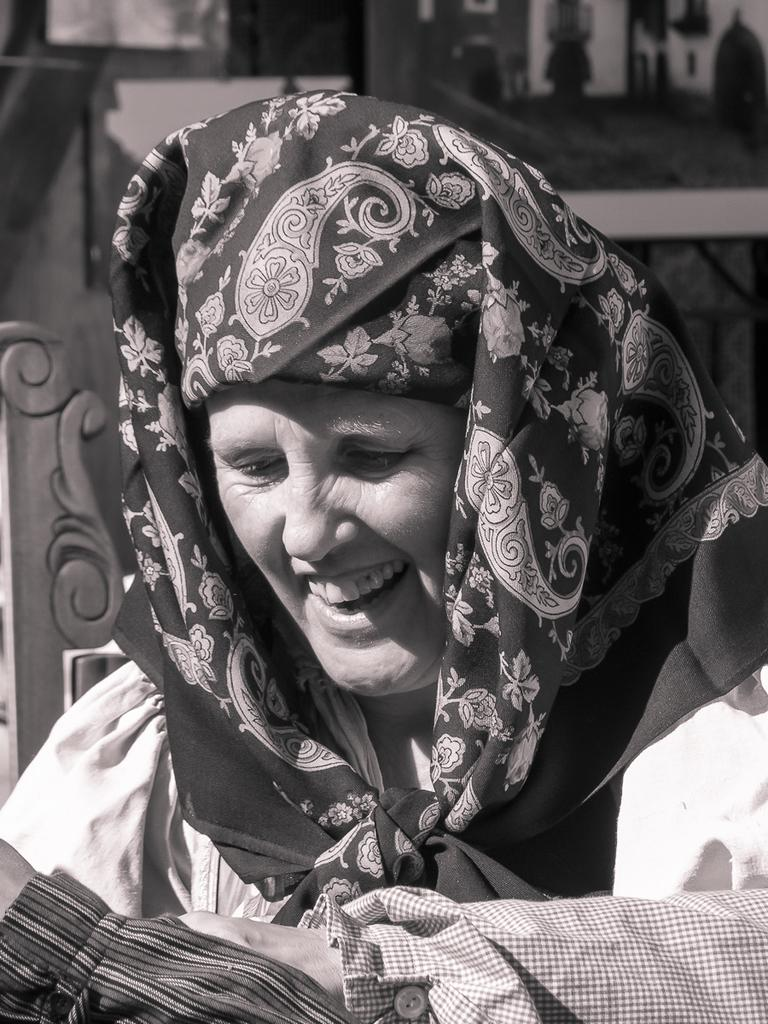What is the main subject of the image? The main subject of the image is a woman. What is the woman doing in the image? The woman is smiling in the image. What type of meat can be seen hanging from the woman's neck in the image? There is no meat present in the image, and the woman is not wearing anything around her neck. 